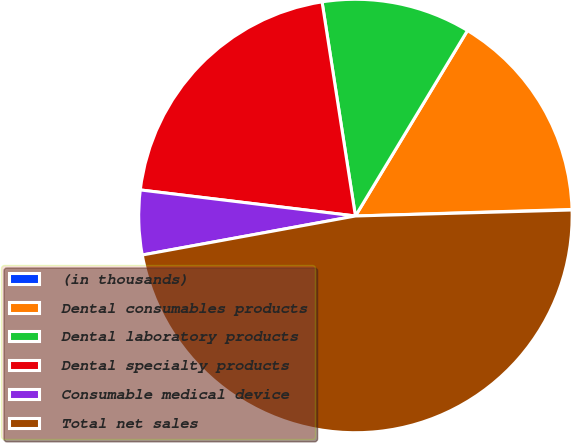Convert chart to OTSL. <chart><loc_0><loc_0><loc_500><loc_500><pie_chart><fcel>(in thousands)<fcel>Dental consumables products<fcel>Dental laboratory products<fcel>Dental specialty products<fcel>Consumable medical device<fcel>Total net sales<nl><fcel>0.04%<fcel>15.87%<fcel>11.11%<fcel>20.62%<fcel>4.8%<fcel>47.56%<nl></chart> 